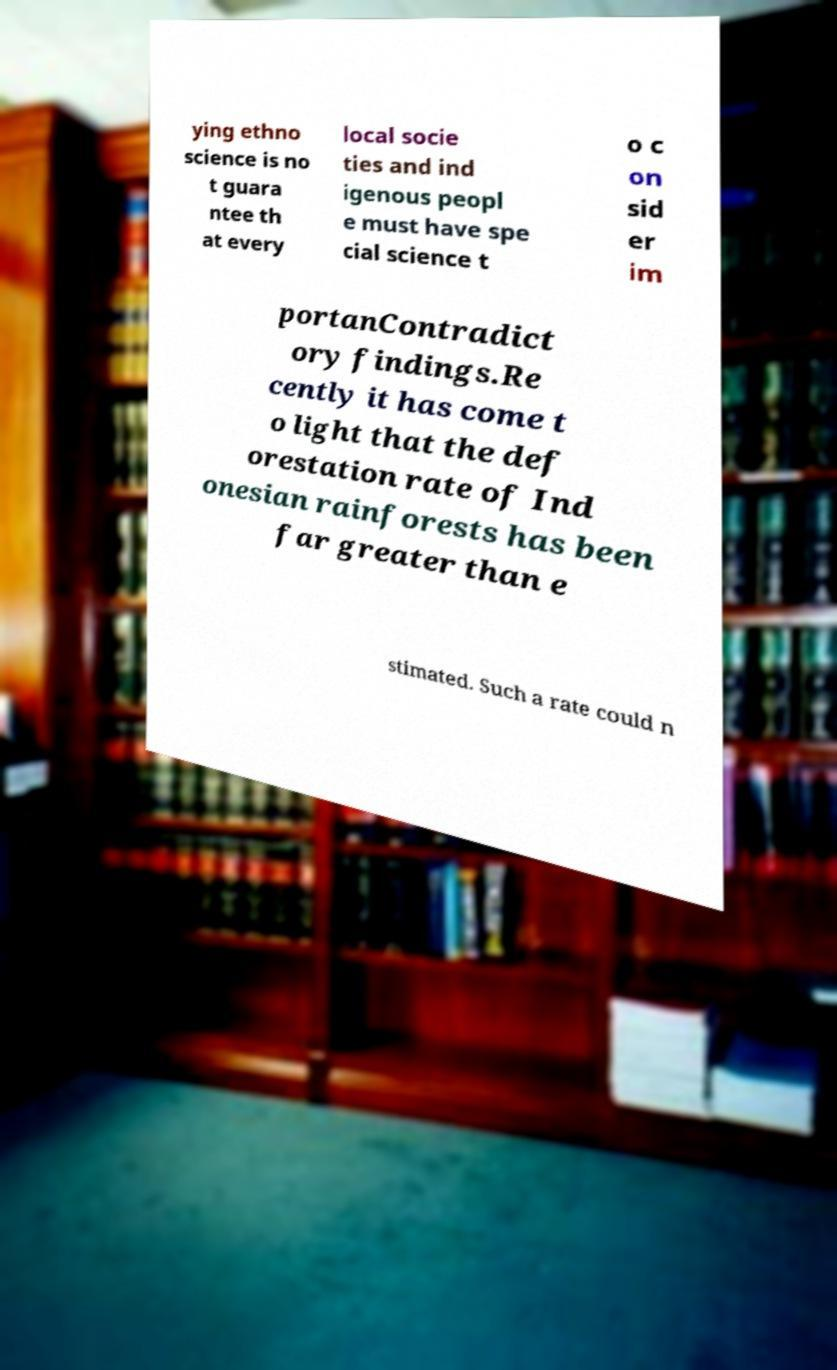Could you extract and type out the text from this image? ying ethno science is no t guara ntee th at every local socie ties and ind igenous peopl e must have spe cial science t o c on sid er im portanContradict ory findings.Re cently it has come t o light that the def orestation rate of Ind onesian rainforests has been far greater than e stimated. Such a rate could n 